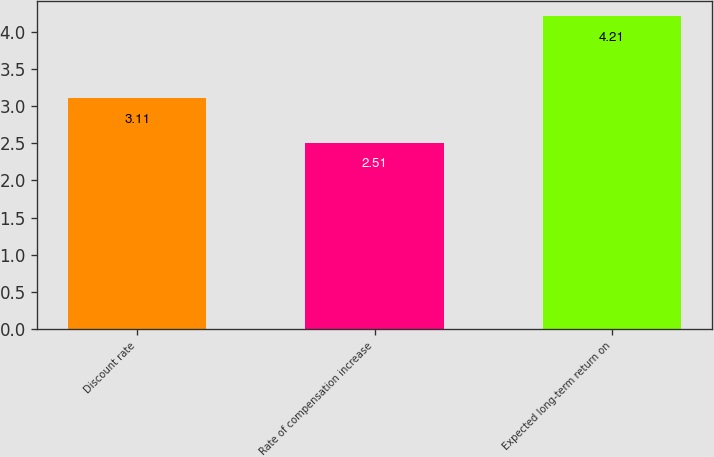Convert chart. <chart><loc_0><loc_0><loc_500><loc_500><bar_chart><fcel>Discount rate<fcel>Rate of compensation increase<fcel>Expected long-term return on<nl><fcel>3.11<fcel>2.51<fcel>4.21<nl></chart> 